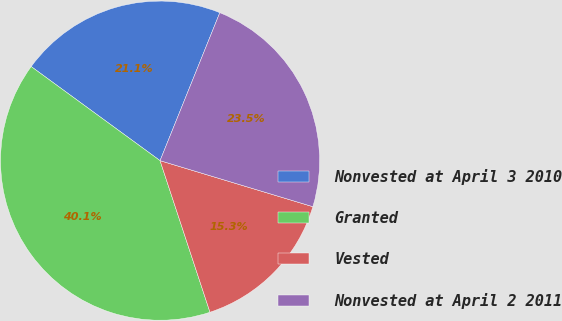Convert chart. <chart><loc_0><loc_0><loc_500><loc_500><pie_chart><fcel>Nonvested at April 3 2010<fcel>Granted<fcel>Vested<fcel>Nonvested at April 2 2011<nl><fcel>21.07%<fcel>40.1%<fcel>15.28%<fcel>23.55%<nl></chart> 